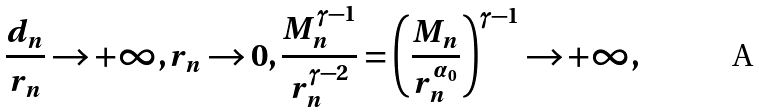Convert formula to latex. <formula><loc_0><loc_0><loc_500><loc_500>\frac { d _ { n } } { r _ { n } } \to + \infty , r _ { n } \to 0 , \frac { M _ { n } ^ { \gamma - 1 } } { r _ { n } ^ { \gamma - 2 } } = \left ( \frac { M _ { n } } { r _ { n } ^ { \alpha _ { 0 } } } \right ) ^ { \gamma - 1 } \to + \infty ,</formula> 